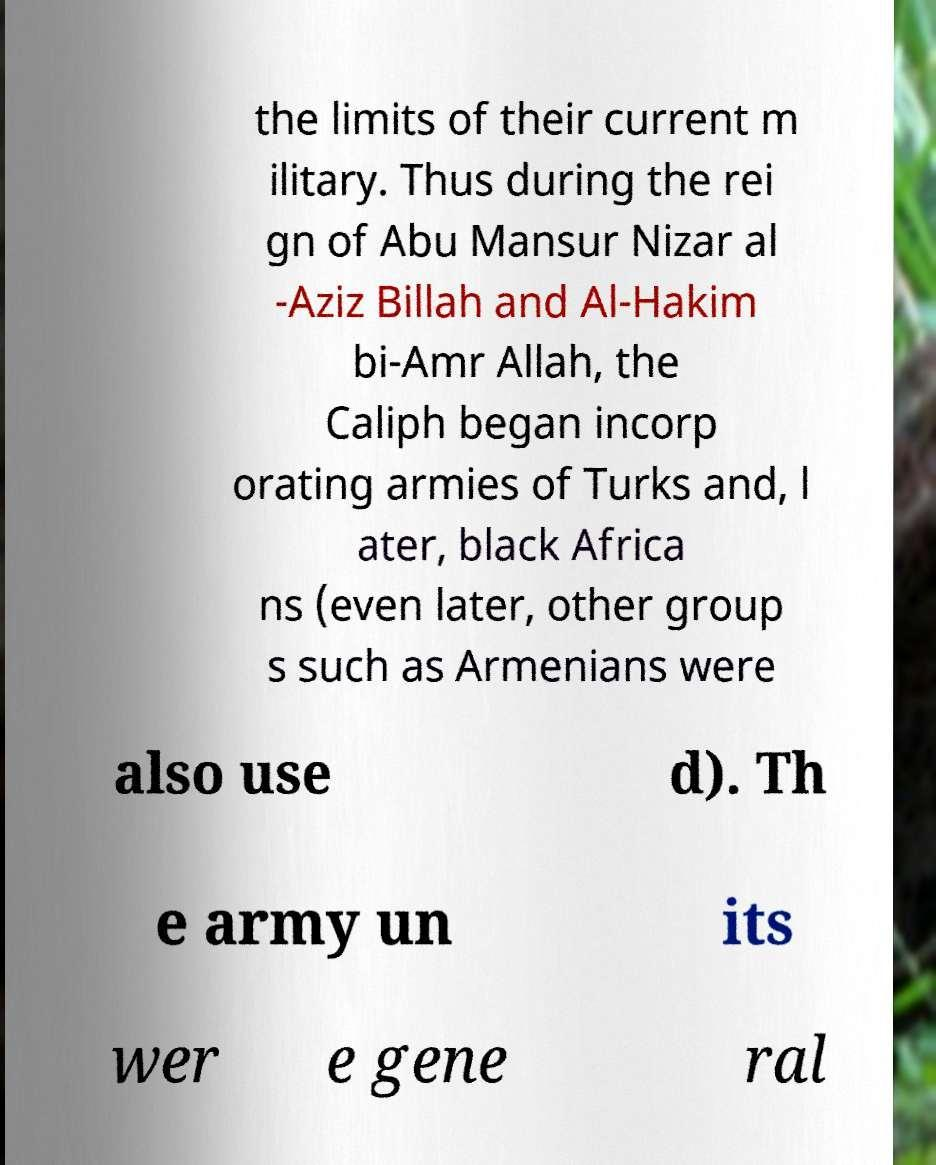I need the written content from this picture converted into text. Can you do that? the limits of their current m ilitary. Thus during the rei gn of Abu Mansur Nizar al -Aziz Billah and Al-Hakim bi-Amr Allah, the Caliph began incorp orating armies of Turks and, l ater, black Africa ns (even later, other group s such as Armenians were also use d). Th e army un its wer e gene ral 